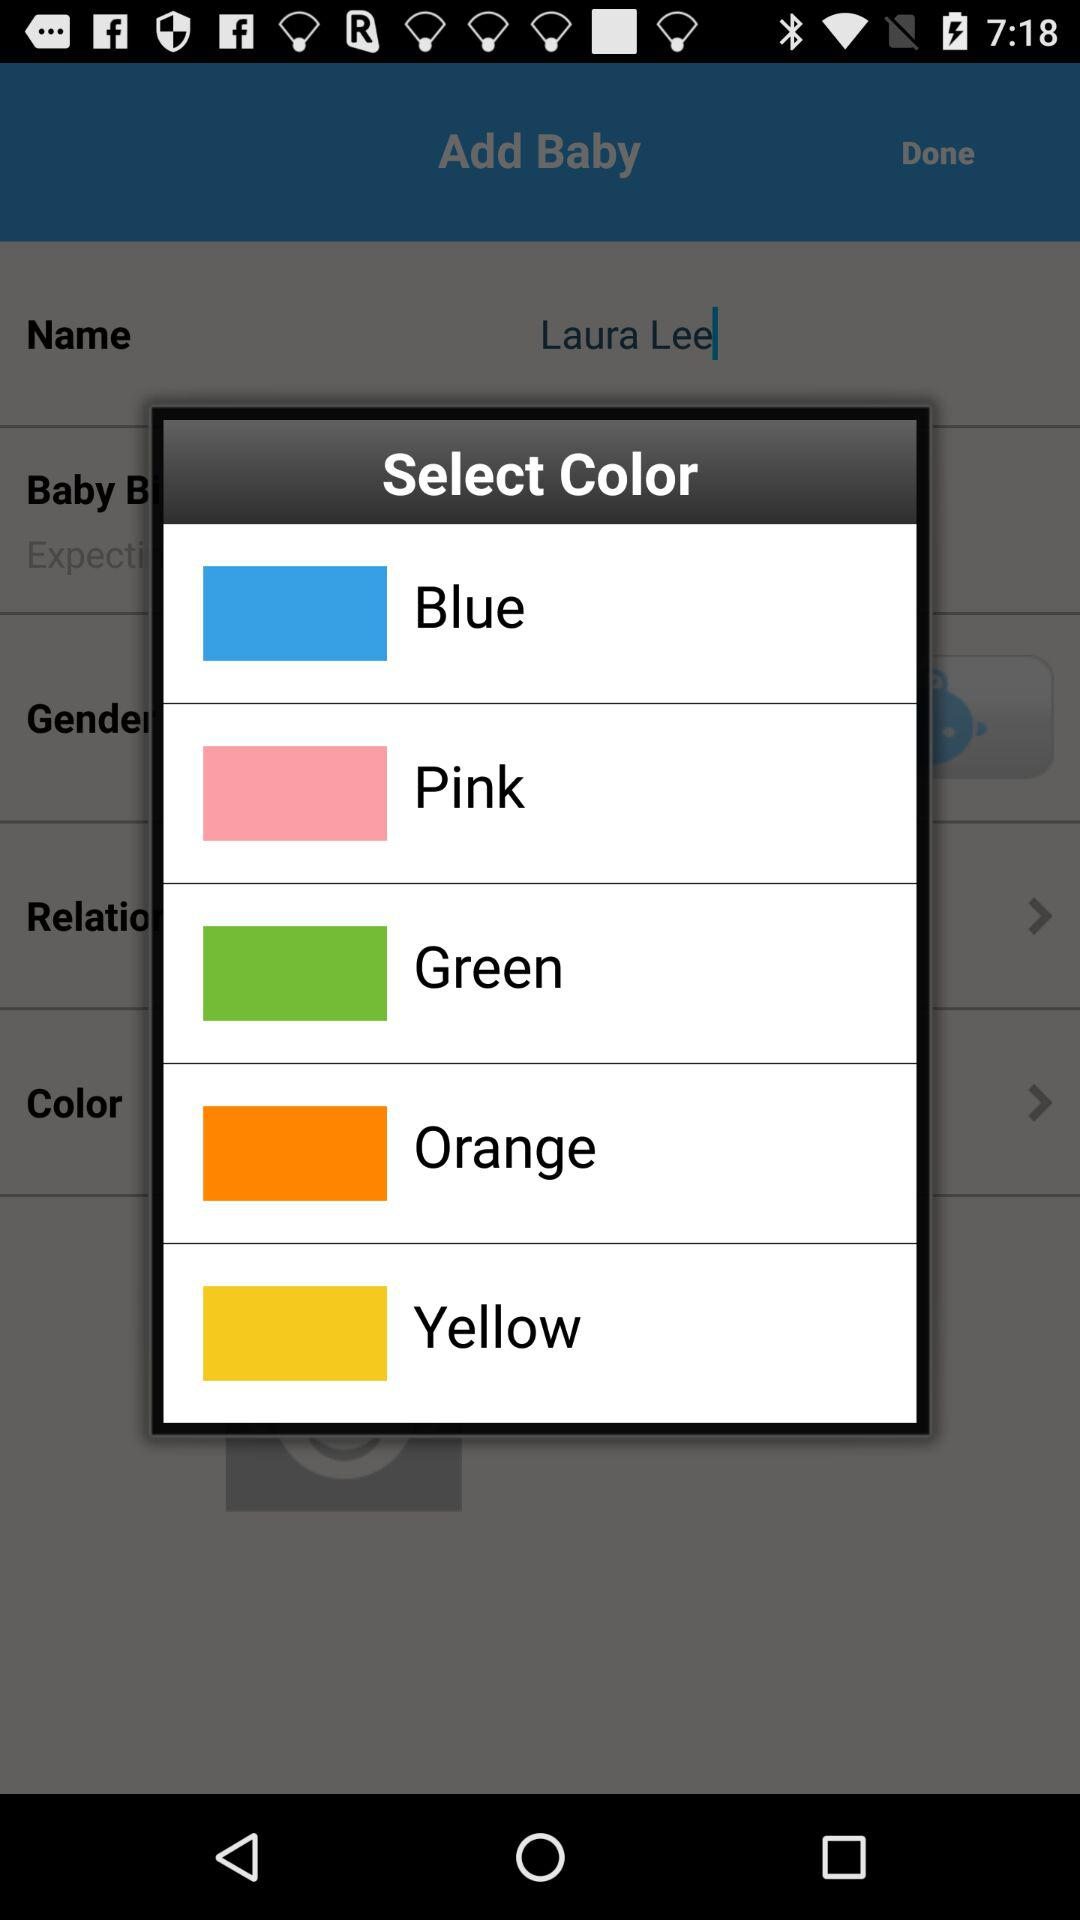How many colors are there?
Answer the question using a single word or phrase. 5 